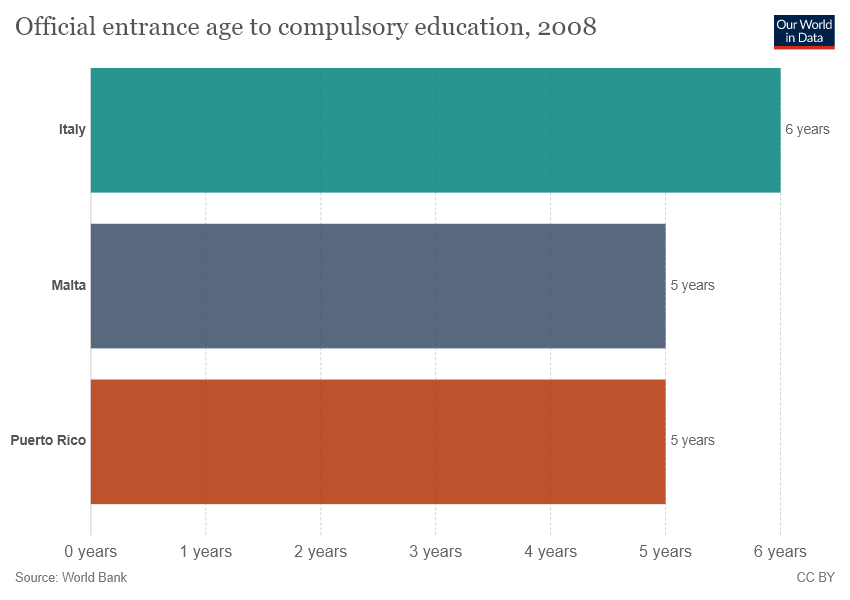Specify some key components in this picture. There are three countries featured in this list. It is generally larger than the median value. 